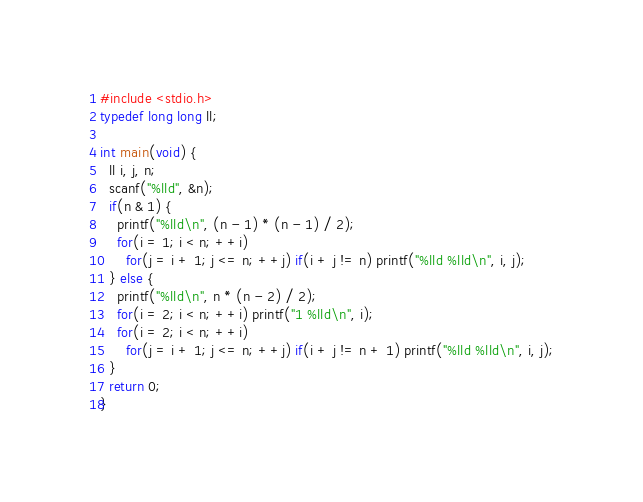<code> <loc_0><loc_0><loc_500><loc_500><_C++_>#include <stdio.h>
typedef long long ll;

int main(void) {
  ll i, j, n;
  scanf("%lld", &n);
  if(n & 1) {
    printf("%lld\n", (n - 1) * (n - 1) / 2);
    for(i = 1; i < n; ++i) 
      for(j = i + 1; j <= n; ++j) if(i + j != n) printf("%lld %lld\n", i, j);
  } else {
    printf("%lld\n", n * (n - 2) / 2);
    for(i = 2; i < n; ++i) printf("1 %lld\n", i);
    for(i = 2; i < n; ++i)
      for(j = i + 1; j <= n; ++j) if(i + j != n + 1) printf("%lld %lld\n", i, j);
  }
  return 0;
}</code> 